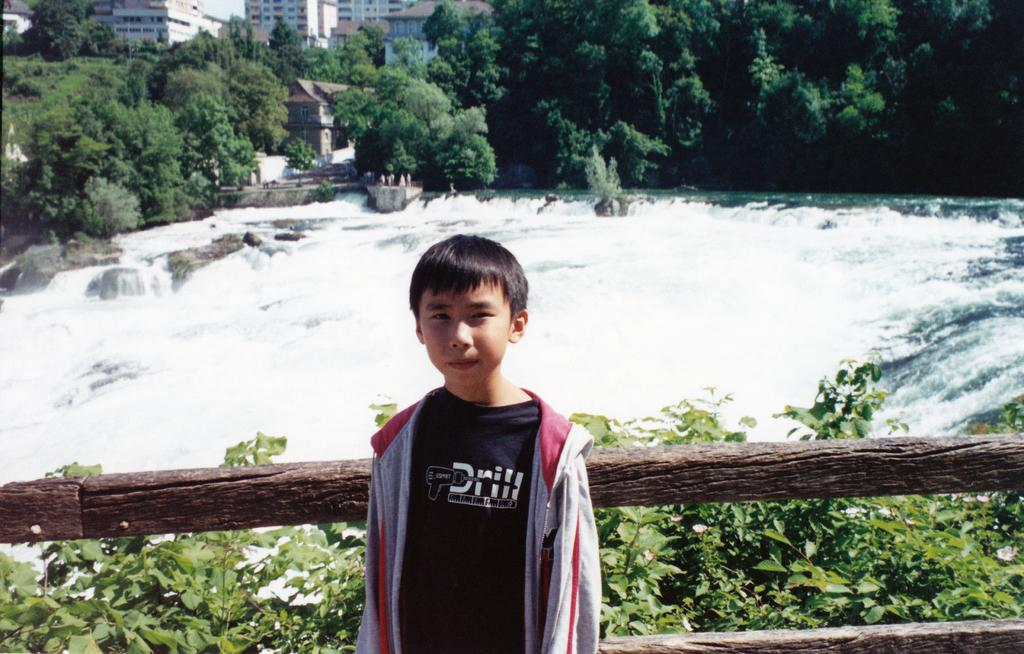What is the main subject of the image? There is a kid in the image. What can be seen in the front of the image? There are plants in the front of the image. What is located in the middle of the image? There is water in the middle of the image. What is visible in the background of the image? There are trees and buildings in the background of the image. What type of destruction can be seen happening to the buildings in the image? There is no destruction visible in the image; the buildings appear intact. Can you tell me how many volleyballs are present in the image? There are no volleyballs present in the image. 